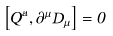<formula> <loc_0><loc_0><loc_500><loc_500>\left [ Q ^ { a } , \partial ^ { \mu } D _ { \mu } \right ] = 0</formula> 